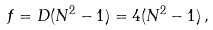<formula> <loc_0><loc_0><loc_500><loc_500>f = D ( N ^ { 2 } - 1 ) = 4 ( N ^ { 2 } - 1 ) \, ,</formula> 